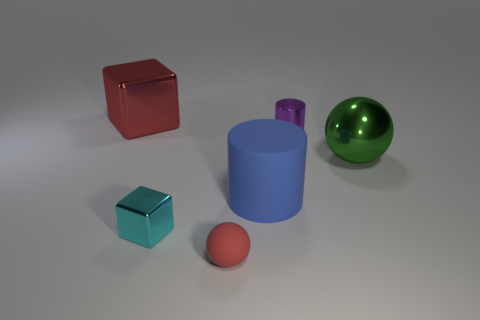How does the texture of the surface upon which the objects are resting impact the perception of their materials? The subtle shadows and light play generated by the matte floor accentuate the differences in material textures among the objects. The metal cube, for example, reflects light, giving it a lustrous appearance in contrast to the non-reflective matte objects. 